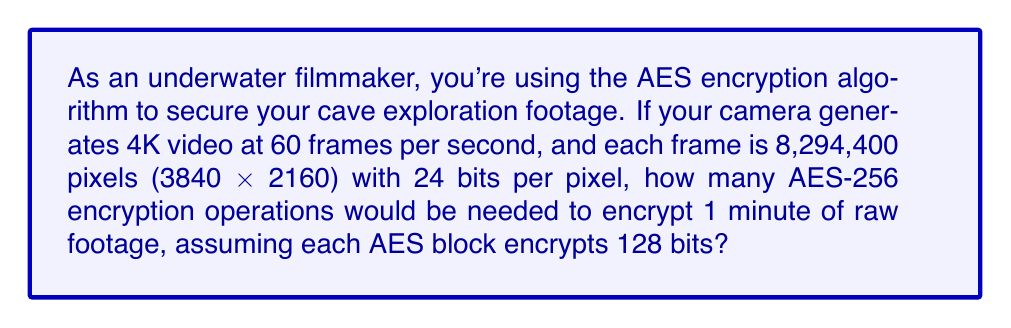Solve this math problem. Let's break this down step-by-step:

1. Calculate the size of one frame:
   $3840 \times 2160 = 8,294,400$ pixels
   $8,294,400 \times 24$ bits = $199,065,600$ bits per frame

2. Calculate the number of frames in 1 minute:
   $60$ frames/second $\times 60$ seconds = $3,600$ frames

3. Calculate the total number of bits in 1 minute of footage:
   $199,065,600$ bits/frame $\times 3,600$ frames = $716,636,160,000$ bits

4. Determine the number of 128-bit blocks in the footage:
   $\frac{716,636,160,000 \text{ bits}}{128 \text{ bits/block}} = 5,598,720,000$ blocks

5. Since each block requires one AES-256 encryption operation, the number of operations is equal to the number of blocks.

Therefore, $5,598,720,000$ AES-256 encryption operations would be needed to encrypt 1 minute of raw footage.
Answer: 5,598,720,000 operations 